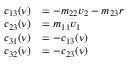<formula> <loc_0><loc_0><loc_500><loc_500>\begin{array} { r l } { c _ { 1 3 } ( \nu ) } & { = - m _ { 2 2 } v _ { 2 } - m _ { 2 3 } { r } } \\ { c _ { 2 3 } ( \nu ) } & { = m _ { 1 1 } v _ { 1 } } \\ { c _ { 3 1 } ( \nu ) } & { = - c _ { 1 3 } ( \nu ) } \\ { c _ { 3 2 } ( \nu ) } & { = - c _ { 2 3 } ( \nu ) } \end{array}</formula> 